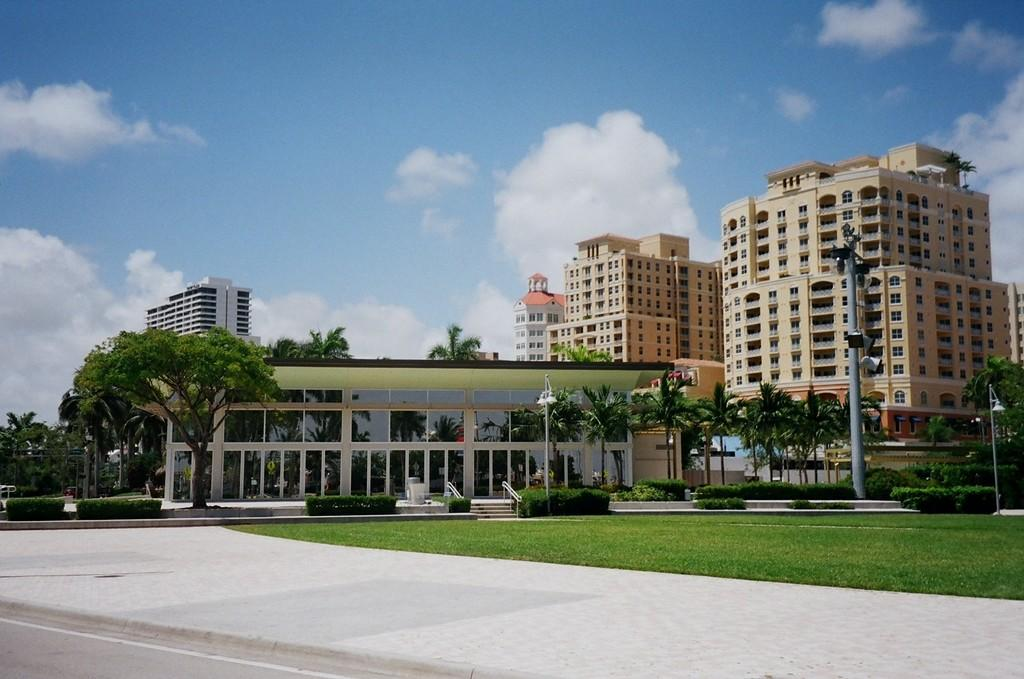What type of structures can be seen in the image? There are buildings in the image. What natural elements are present in the image? There are trees, plants, and grass in the image. What man-made feature can be seen in the image? There is a road in the image. What are the poles used for in the image? The poles are likely used for supporting wires or signs. What is visible in the background of the image? The sky is visible in the background of the image, with clouds present. Where is the lunchroom located in the image? There is no mention of a lunchroom in the image; it features buildings, trees, plants, grass, a road, poles, and a sky with clouds. What is the cause of the clouds in the image? The cause of the clouds in the image cannot be determined from the image itself, as it only shows the clouds and not the weather conditions or atmospheric processes that led to their formation. 